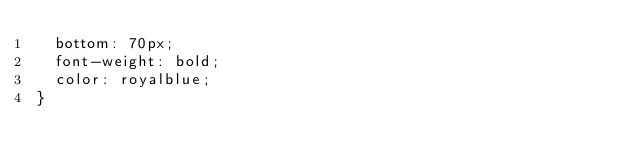<code> <loc_0><loc_0><loc_500><loc_500><_CSS_>  bottom: 70px;
  font-weight: bold;
  color: royalblue;
}
</code> 